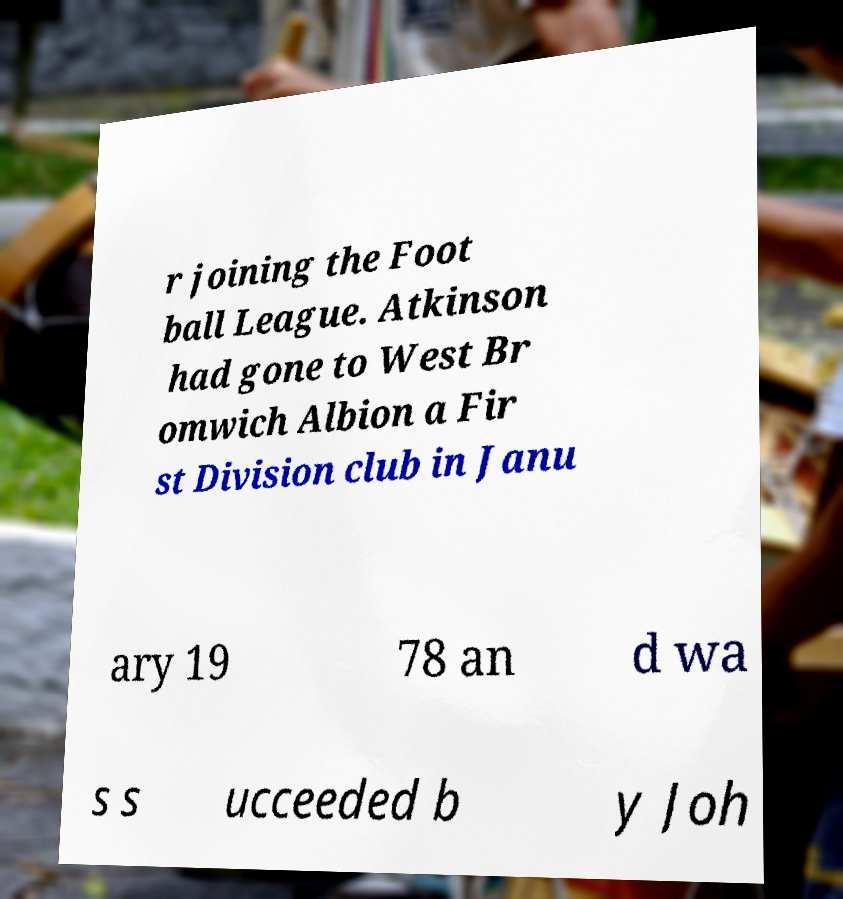Can you accurately transcribe the text from the provided image for me? r joining the Foot ball League. Atkinson had gone to West Br omwich Albion a Fir st Division club in Janu ary 19 78 an d wa s s ucceeded b y Joh 